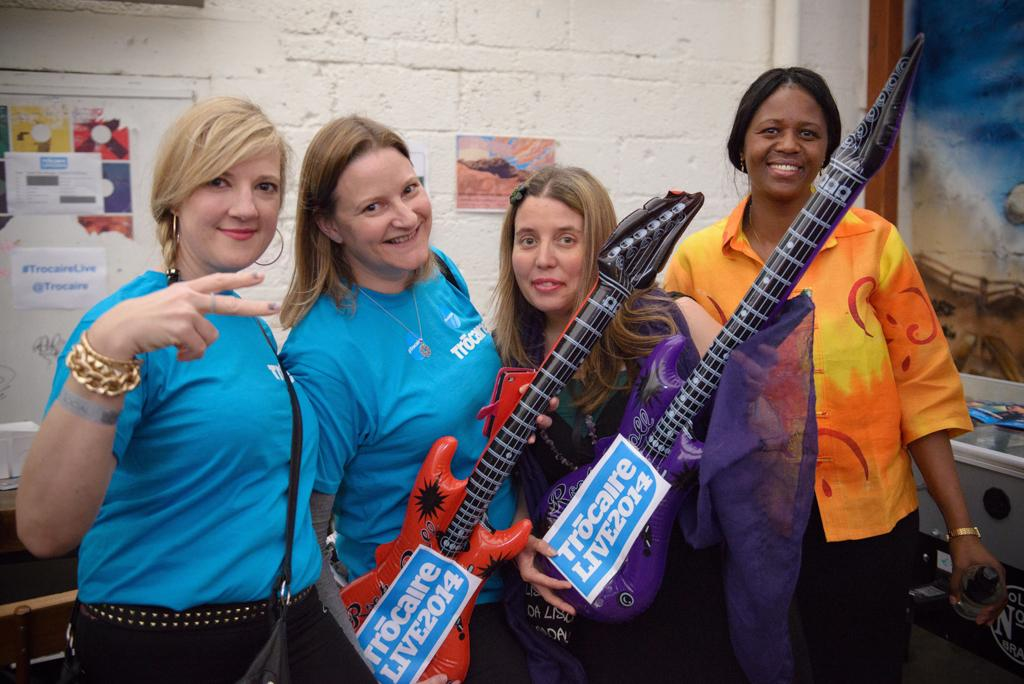How many women are in the image? Four women are standing and posing for stills. What are two of the women holding? Two of the women are holding a guitar. What can be seen on the wall in the image? There are different types of posters on the wall. What is one woman holding in the image? One woman is holding a bottle. What type of behavior is the deer exhibiting in the image? There is no deer present in the image, so it is not possible to determine the behavior of a deer. 